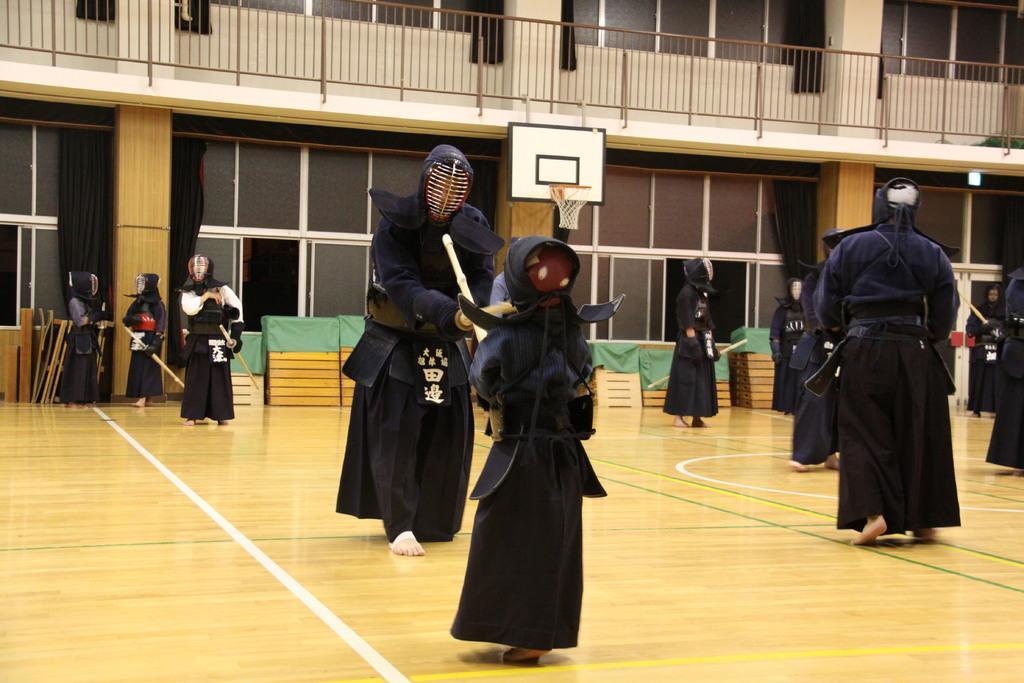Could you give a brief overview of what you see in this image? In this image there are some persons wearing kendo dress as we can see in the middle of this image. There is a basketball ground in the bottom of this image. There is a building in the background. There are some glass windows in the bottom of this building and there is a fencing on the top of this image. 